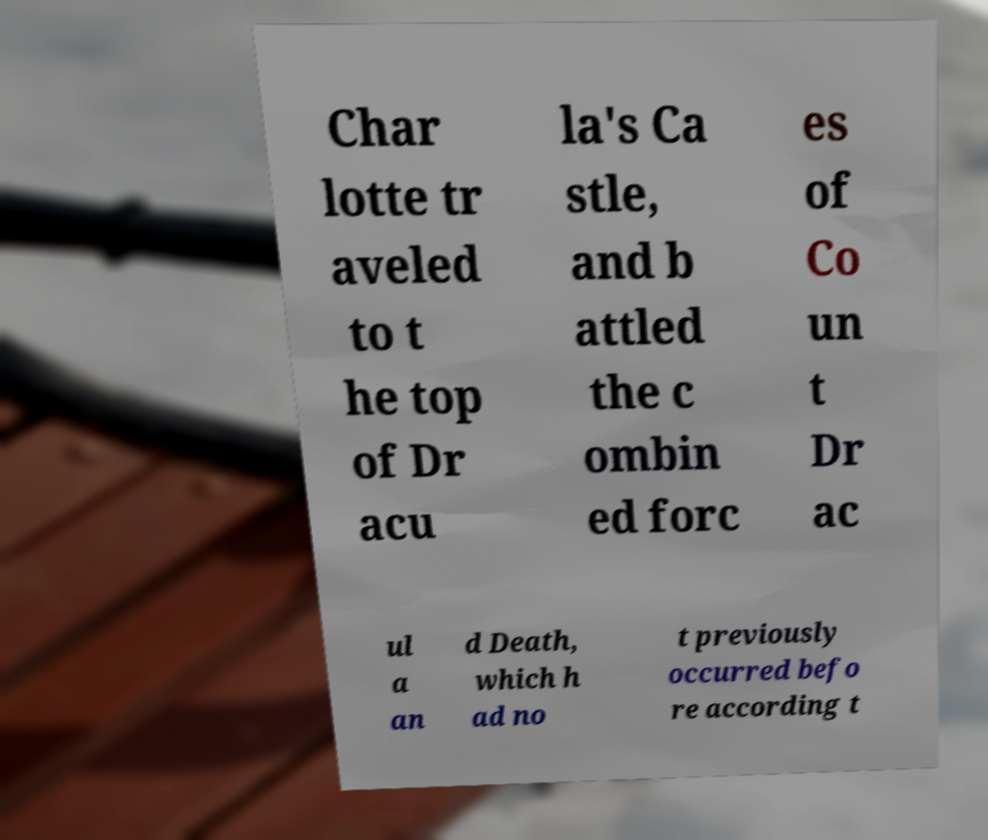What messages or text are displayed in this image? I need them in a readable, typed format. Char lotte tr aveled to t he top of Dr acu la's Ca stle, and b attled the c ombin ed forc es of Co un t Dr ac ul a an d Death, which h ad no t previously occurred befo re according t 